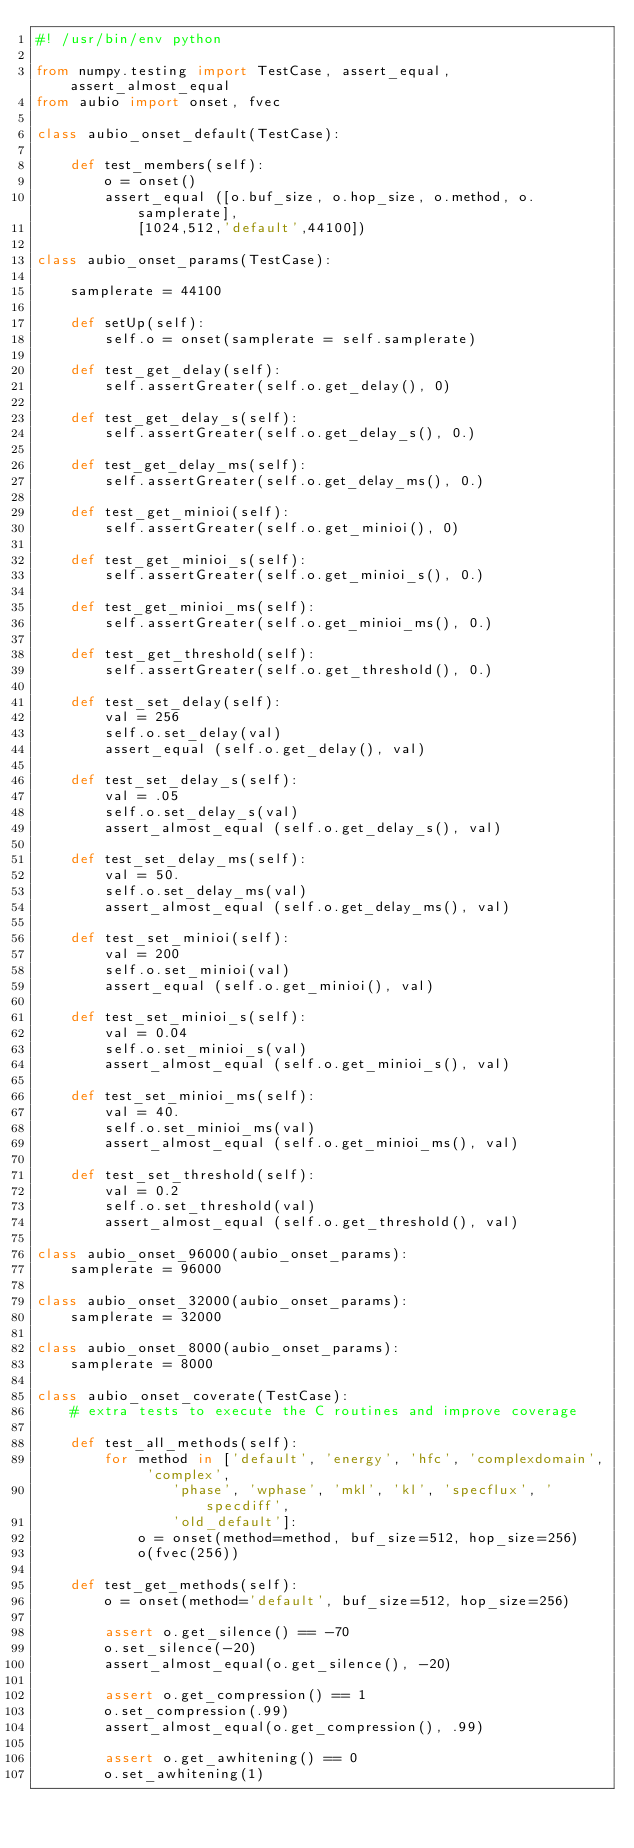<code> <loc_0><loc_0><loc_500><loc_500><_Python_>#! /usr/bin/env python

from numpy.testing import TestCase, assert_equal, assert_almost_equal
from aubio import onset, fvec

class aubio_onset_default(TestCase):

    def test_members(self):
        o = onset()
        assert_equal ([o.buf_size, o.hop_size, o.method, o.samplerate],
            [1024,512,'default',44100])

class aubio_onset_params(TestCase):

    samplerate = 44100

    def setUp(self):
        self.o = onset(samplerate = self.samplerate)

    def test_get_delay(self):
        self.assertGreater(self.o.get_delay(), 0)

    def test_get_delay_s(self):
        self.assertGreater(self.o.get_delay_s(), 0.)

    def test_get_delay_ms(self):
        self.assertGreater(self.o.get_delay_ms(), 0.)

    def test_get_minioi(self):
        self.assertGreater(self.o.get_minioi(), 0)

    def test_get_minioi_s(self):
        self.assertGreater(self.o.get_minioi_s(), 0.)

    def test_get_minioi_ms(self):
        self.assertGreater(self.o.get_minioi_ms(), 0.)

    def test_get_threshold(self):
        self.assertGreater(self.o.get_threshold(), 0.)

    def test_set_delay(self):
        val = 256
        self.o.set_delay(val)
        assert_equal (self.o.get_delay(), val)

    def test_set_delay_s(self):
        val = .05
        self.o.set_delay_s(val)
        assert_almost_equal (self.o.get_delay_s(), val)

    def test_set_delay_ms(self):
        val = 50.
        self.o.set_delay_ms(val)
        assert_almost_equal (self.o.get_delay_ms(), val)

    def test_set_minioi(self):
        val = 200
        self.o.set_minioi(val)
        assert_equal (self.o.get_minioi(), val)

    def test_set_minioi_s(self):
        val = 0.04
        self.o.set_minioi_s(val)
        assert_almost_equal (self.o.get_minioi_s(), val)

    def test_set_minioi_ms(self):
        val = 40.
        self.o.set_minioi_ms(val)
        assert_almost_equal (self.o.get_minioi_ms(), val)

    def test_set_threshold(self):
        val = 0.2
        self.o.set_threshold(val)
        assert_almost_equal (self.o.get_threshold(), val)

class aubio_onset_96000(aubio_onset_params):
    samplerate = 96000

class aubio_onset_32000(aubio_onset_params):
    samplerate = 32000

class aubio_onset_8000(aubio_onset_params):
    samplerate = 8000

class aubio_onset_coverate(TestCase):
    # extra tests to execute the C routines and improve coverage

    def test_all_methods(self):
        for method in ['default', 'energy', 'hfc', 'complexdomain', 'complex',
                'phase', 'wphase', 'mkl', 'kl', 'specflux', 'specdiff',
                'old_default']:
            o = onset(method=method, buf_size=512, hop_size=256)
            o(fvec(256))

    def test_get_methods(self):
        o = onset(method='default', buf_size=512, hop_size=256)

        assert o.get_silence() == -70
        o.set_silence(-20)
        assert_almost_equal(o.get_silence(), -20)

        assert o.get_compression() == 1
        o.set_compression(.99)
        assert_almost_equal(o.get_compression(), .99)

        assert o.get_awhitening() == 0
        o.set_awhitening(1)</code> 